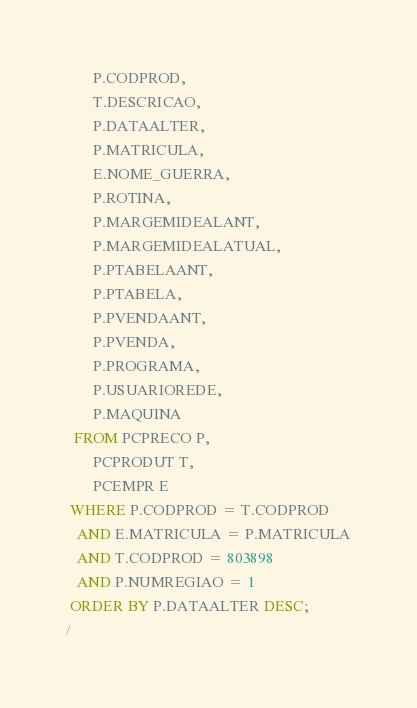<code> <loc_0><loc_0><loc_500><loc_500><_SQL_>       P.CODPROD,
       T.DESCRICAO,
       P.DATAALTER,
       P.MATRICULA,
       E.NOME_GUERRA,
       P.ROTINA,
       P.MARGEMIDEALANT,
       P.MARGEMIDEALATUAL,
       P.PTABELAANT,
       P.PTABELA,
       P.PVENDAANT,
       P.PVENDA,
       P.PROGRAMA,
       P.USUARIOREDE,
       P.MAQUINA
  FROM PCPRECO P,
       PCPRODUT T,
       PCEMPR E
 WHERE P.CODPROD = T.CODPROD
   AND E.MATRICULA = P.MATRICULA
   AND T.CODPROD = 803898
   AND P.NUMREGIAO = 1
 ORDER BY P.DATAALTER DESC;
/</code> 